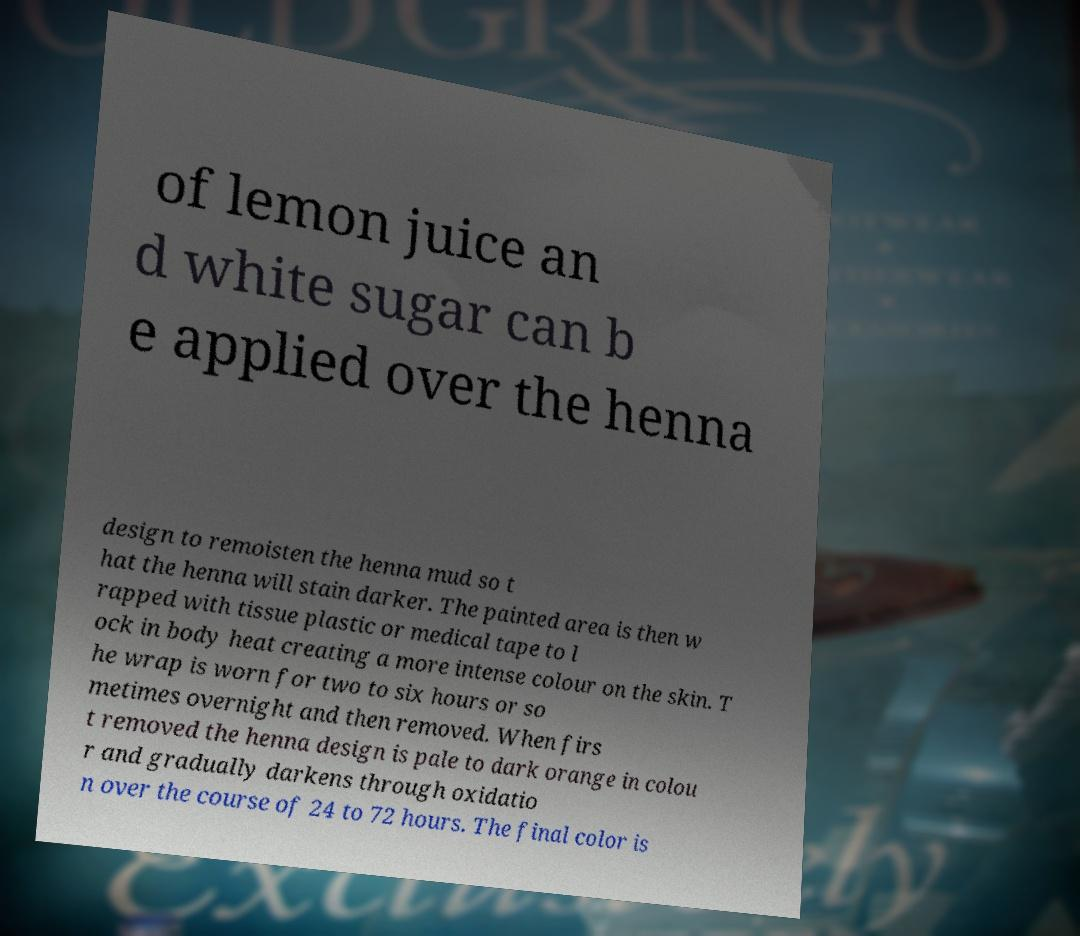There's text embedded in this image that I need extracted. Can you transcribe it verbatim? of lemon juice an d white sugar can b e applied over the henna design to remoisten the henna mud so t hat the henna will stain darker. The painted area is then w rapped with tissue plastic or medical tape to l ock in body heat creating a more intense colour on the skin. T he wrap is worn for two to six hours or so metimes overnight and then removed. When firs t removed the henna design is pale to dark orange in colou r and gradually darkens through oxidatio n over the course of 24 to 72 hours. The final color is 